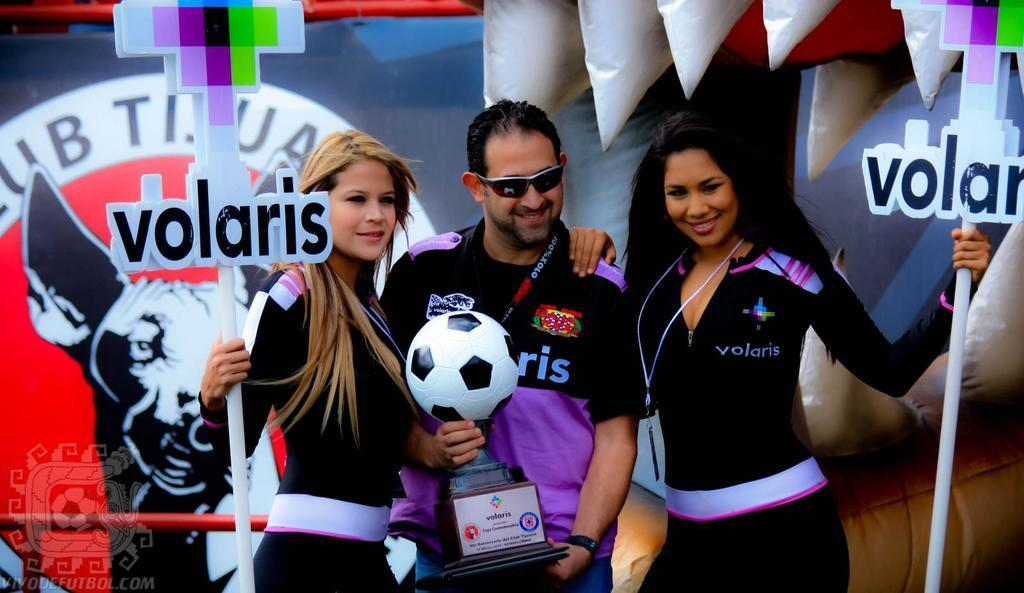Provide a one-sentence caption for the provided image. Two women holding signs for Volaris stand next to a man holding a soccer ball. 